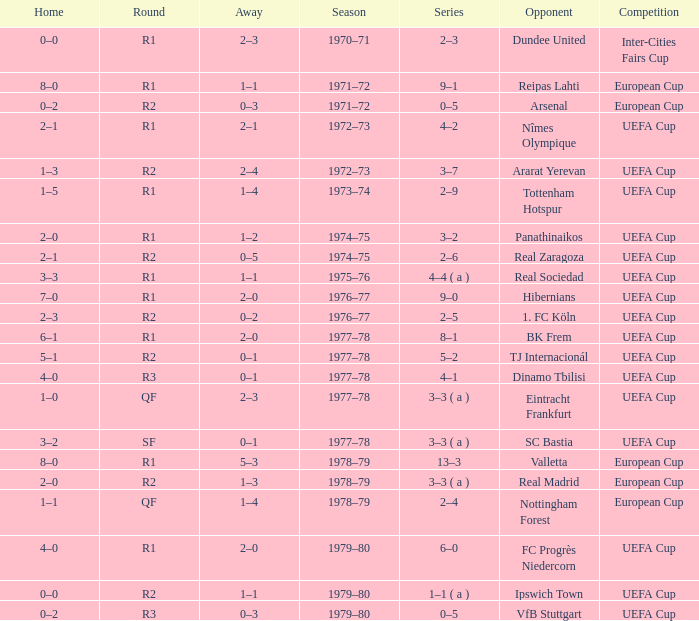Which Round has a Competition of uefa cup, and a Series of 5–2? R2. 